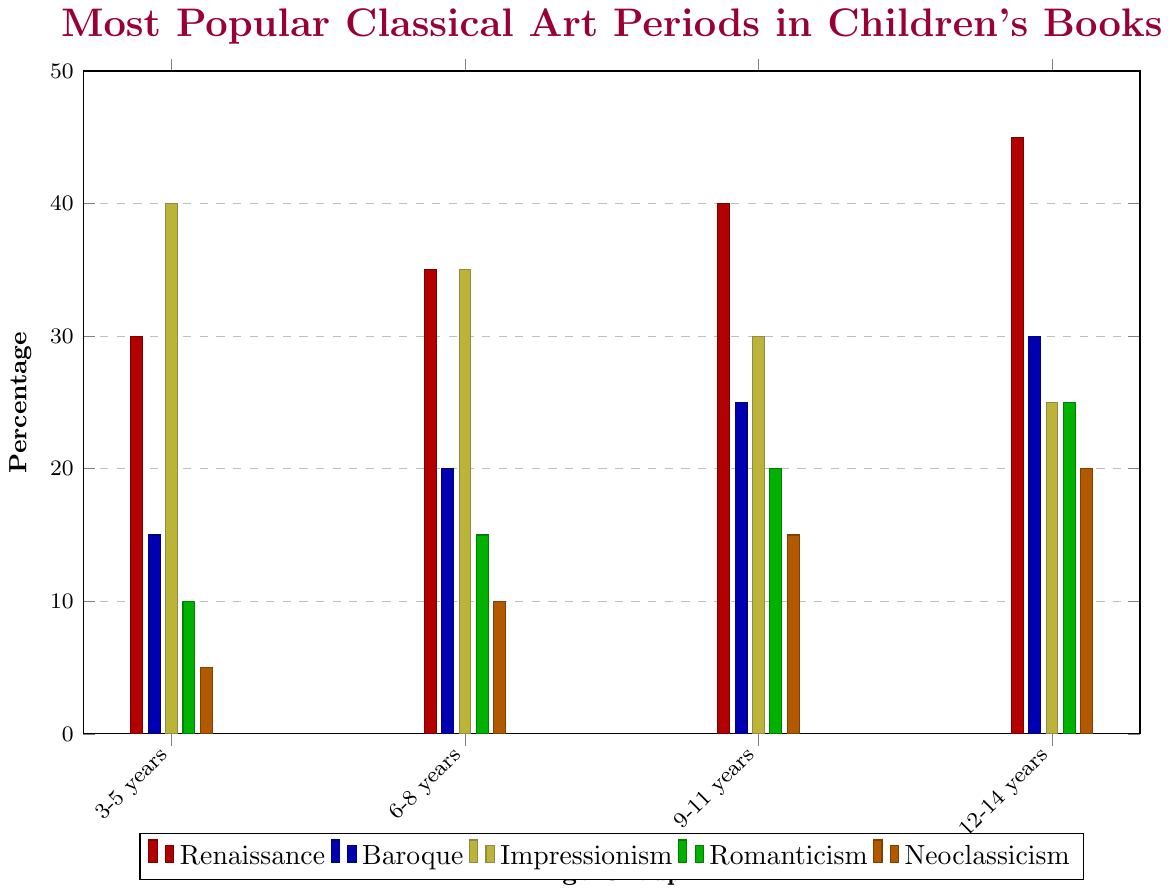What is the most popular classical art period among 9-11 year-olds? Look at the highest bar in the 9-11 years age group. The tallest bar is yellow (Impressionism) with a height of 30%
Answer: Impressionism Which age group shows the highest interest in Baroque art? Check which age group has the tallest blue bar. The 12-14 years age group has the highest bar at 30% for Baroque art
Answer: 12-14 years What is the total percentage of children who prefer Neoclassicism from 3-5 years and 6-8 years combined? Sum the percentages for Neoclassicism in the 3-5 years (5%) and 6-8 years (10%) age groups. 5% + 10% = 15%
Answer: 15% Which classical art period has a declining trend as children grow older? Identify the trend by comparing bar heights across age groups. Impressionism (yellow) decreases from 40% (3-5 years) to 25% (12-14 years)
Answer: Impressionism How many percentage points higher is Renaissance popularity among 12-14 year-olds compared to 3-5 year-olds? Subtract the percentage of Renaissance in 3-5 years (30%) from the percentage in 12-14 years (45%). 45% - 30% = 15%
Answer: 15% Between Renaissance and Romanticism, which is more popular among 6-8 year-olds and by how many percentage points? Compare the heights of the red (Renaissance) and green (Romanticism) bars for the 6-8 years age group. Renaissance is 35% and Romanticism is 15%. 35% - 15% = 20%
Answer: Renaissance by 20% Which classical art period has the least interest among children aged 3-5 years? Find the shortest bar in the 3-5 years age group. The shortest bar is orange (Neoclassicism) with 5%
Answer: Neoclassicism What is the average percentage of children who prefer Romanticism across all age groups? Add the percentages for Romanticism across all age groups (10% + 15% + 20% + 25%) and divide by 4. (10% + 15% + 20% + 25%) / 4 = 17.5%
Answer: 17.5% How does the popularity of Impressionism change from 3-5 years to 12-14 years? Compare the Impressionism percentages in 3-5 years (40%) and 12-14 years (25%). The popularity decreases by 40% - 25% = 15%
Answer: Decreases by 15% Which age group has the most balanced preference across the different art periods? Check the age group where the bar heights are more uniform across different art periods. For 12-14 years, the percentages range from 20% to 45%, which is the most balanced compared to other age groups
Answer: 12-14 years 